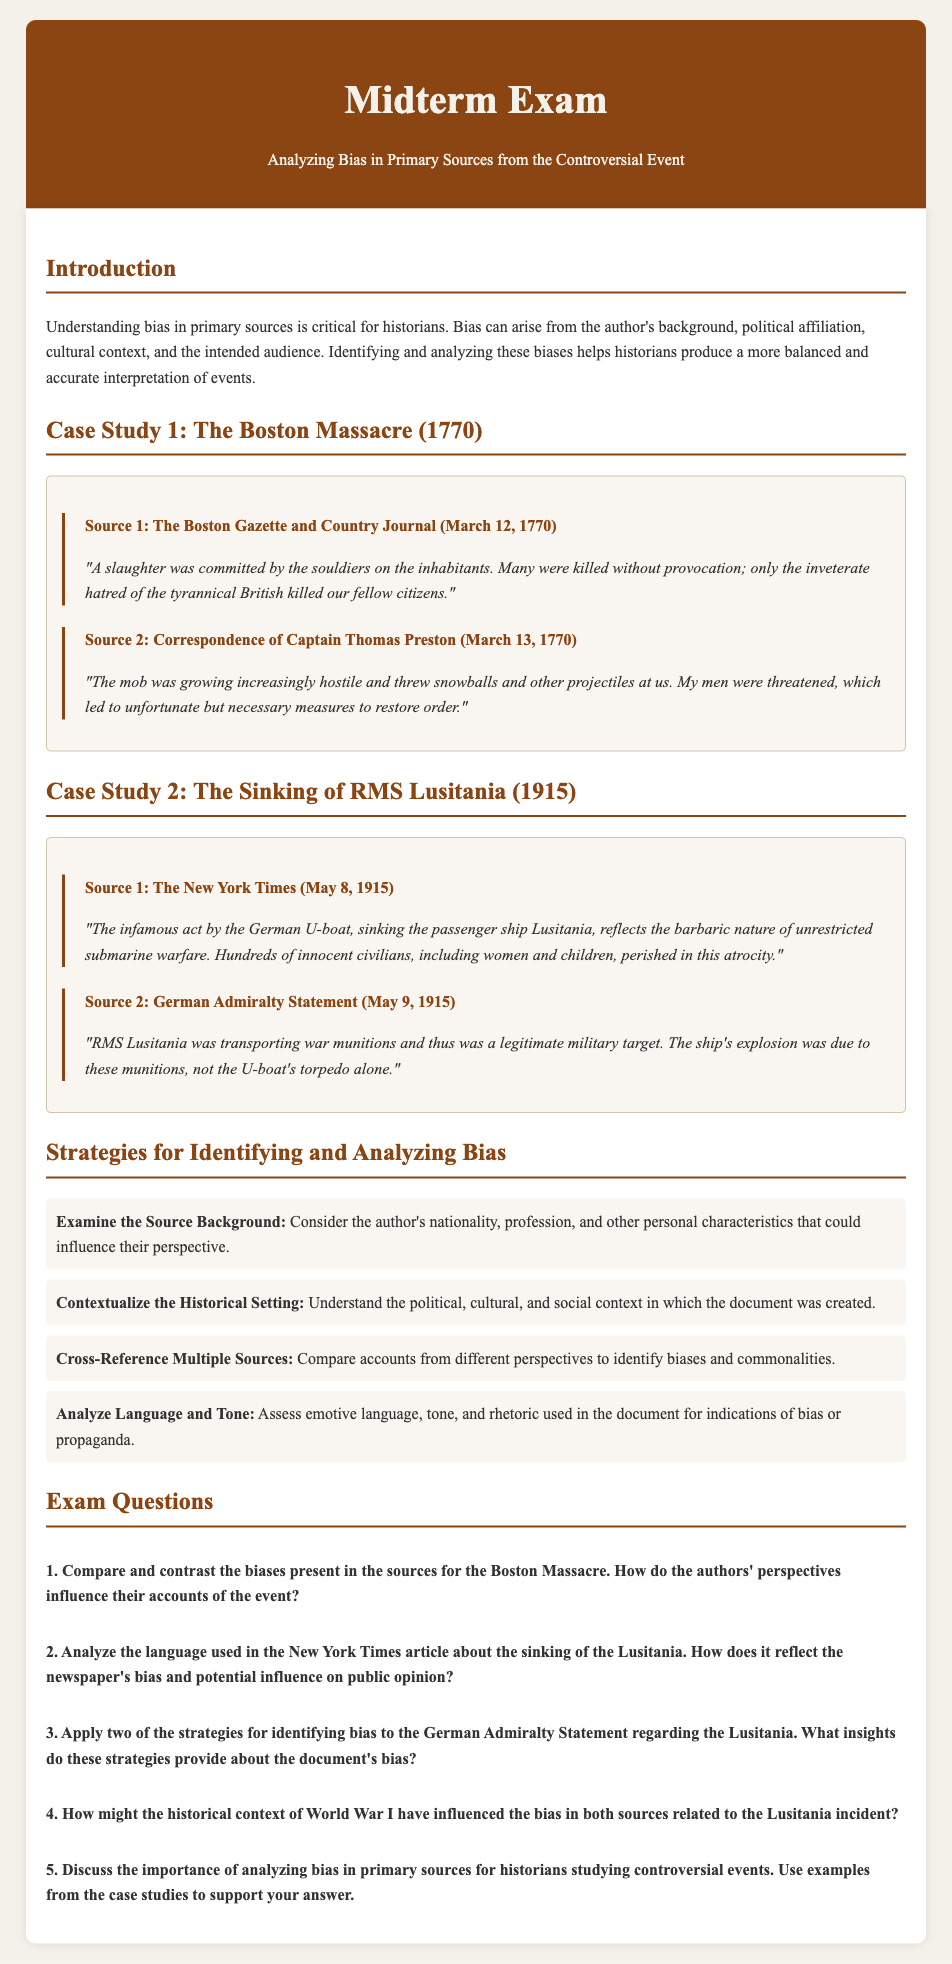What is the title of the midterm exam? The title is clearly stated in the document's header section.
Answer: Analyzing Bias in Primary Sources from the Controversial Event When was the Boston Massacre documented in The Boston Gazette and Country Journal? The publication date is mentioned next to the source title.
Answer: March 12, 1770 Who wrote the correspondence referenced for Case Study 1? The author of the correspondence is indicated in the source title.
Answer: Captain Thomas Preston What primary source presents the sinking of the Lusitania from a German perspective? The source is explicitly named in the case study section.
Answer: German Admiralty Statement Which strategy suggests comparing accounts from different perspectives? This strategy is listed under the strategies for identifying bias.
Answer: Cross-Reference Multiple Sources According to the New York Times article, what was the event described as reflecting the barbaric nature of warfare? This statement is found in the summary of the source content.
Answer: Sinking of the passenger ship Lusitania How did the German Admiralty view the RMS Lusitania? The German Admiralty's perspective is explicitly noted in the source.
Answer: A legitimate military target What context does the document suggest influenced the bias in the sources related to the Lusitania? This context is discussed in one of the exam questions.
Answer: Historical context of World War I How many case studies are presented in the document? The number of case studies is detailed in the sections of the document.
Answer: Two 